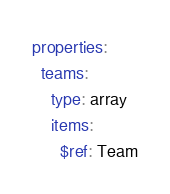Convert code to text. <code><loc_0><loc_0><loc_500><loc_500><_YAML_>
properties:
  teams:
    type: array
    items:
      $ref: Team
</code> 